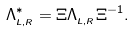<formula> <loc_0><loc_0><loc_500><loc_500>\Lambda _ { _ { L , R } } ^ { \ast } = \Xi \Lambda _ { _ { L , R } } \Xi ^ { - 1 } .</formula> 